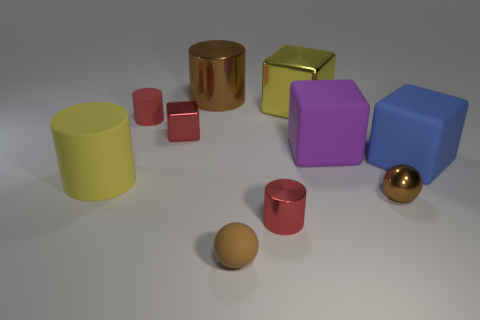There is another ball that is the same color as the shiny ball; what is its material?
Offer a very short reply. Rubber. Do the blue object and the big brown thing have the same material?
Provide a succinct answer. No. There is a tiny brown rubber thing; are there any tiny metallic cylinders on the left side of it?
Your response must be concise. No. There is a big cylinder that is right of the matte cylinder behind the large purple block; what is its material?
Make the answer very short. Metal. There is another matte thing that is the same shape as the big purple matte thing; what size is it?
Your response must be concise. Large. Is the color of the tiny metal cylinder the same as the rubber sphere?
Your answer should be very brief. No. What color is the rubber thing that is to the right of the yellow matte cylinder and in front of the big blue matte object?
Provide a succinct answer. Brown. There is a ball that is behind the brown rubber ball; is its size the same as the purple block?
Provide a short and direct response. No. Are there any other things that have the same shape as the purple thing?
Provide a succinct answer. Yes. Does the big brown cylinder have the same material as the small red cylinder that is in front of the tiny red rubber cylinder?
Ensure brevity in your answer.  Yes. 